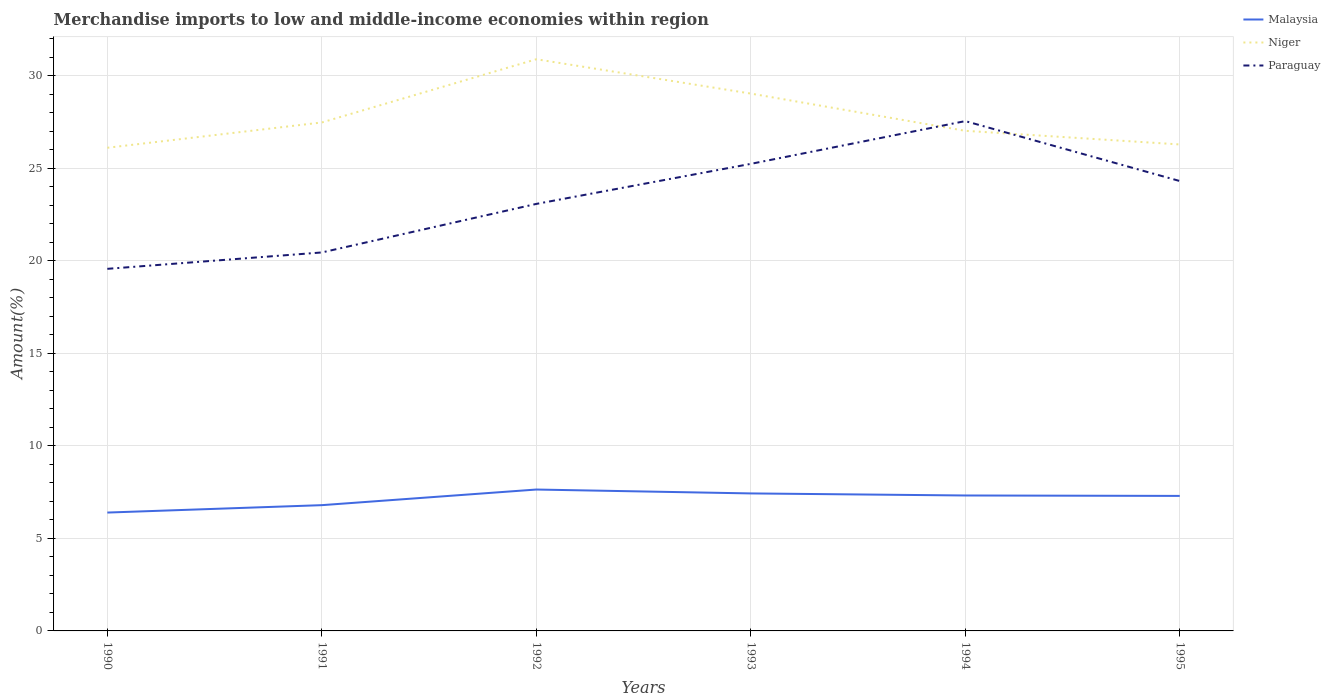Does the line corresponding to Paraguay intersect with the line corresponding to Malaysia?
Your answer should be very brief. No. Is the number of lines equal to the number of legend labels?
Your answer should be compact. Yes. Across all years, what is the maximum percentage of amount earned from merchandise imports in Malaysia?
Your answer should be very brief. 6.4. What is the total percentage of amount earned from merchandise imports in Malaysia in the graph?
Offer a terse response. -0.4. What is the difference between the highest and the second highest percentage of amount earned from merchandise imports in Malaysia?
Offer a very short reply. 1.24. What is the difference between the highest and the lowest percentage of amount earned from merchandise imports in Niger?
Provide a succinct answer. 2. Is the percentage of amount earned from merchandise imports in Niger strictly greater than the percentage of amount earned from merchandise imports in Paraguay over the years?
Offer a very short reply. No. How many lines are there?
Your response must be concise. 3. What is the difference between two consecutive major ticks on the Y-axis?
Make the answer very short. 5. Are the values on the major ticks of Y-axis written in scientific E-notation?
Provide a succinct answer. No. Does the graph contain grids?
Keep it short and to the point. Yes. How many legend labels are there?
Offer a terse response. 3. How are the legend labels stacked?
Make the answer very short. Vertical. What is the title of the graph?
Make the answer very short. Merchandise imports to low and middle-income economies within region. What is the label or title of the Y-axis?
Your answer should be compact. Amount(%). What is the Amount(%) of Malaysia in 1990?
Give a very brief answer. 6.4. What is the Amount(%) in Niger in 1990?
Provide a succinct answer. 26.11. What is the Amount(%) of Paraguay in 1990?
Give a very brief answer. 19.56. What is the Amount(%) in Malaysia in 1991?
Your answer should be very brief. 6.8. What is the Amount(%) of Niger in 1991?
Ensure brevity in your answer.  27.47. What is the Amount(%) of Paraguay in 1991?
Your response must be concise. 20.45. What is the Amount(%) in Malaysia in 1992?
Your answer should be compact. 7.64. What is the Amount(%) in Niger in 1992?
Your answer should be very brief. 30.89. What is the Amount(%) of Paraguay in 1992?
Make the answer very short. 23.07. What is the Amount(%) of Malaysia in 1993?
Make the answer very short. 7.43. What is the Amount(%) of Niger in 1993?
Offer a terse response. 29.03. What is the Amount(%) of Paraguay in 1993?
Provide a short and direct response. 25.24. What is the Amount(%) in Malaysia in 1994?
Your response must be concise. 7.32. What is the Amount(%) in Niger in 1994?
Offer a terse response. 27.02. What is the Amount(%) in Paraguay in 1994?
Your response must be concise. 27.55. What is the Amount(%) in Malaysia in 1995?
Your response must be concise. 7.3. What is the Amount(%) of Niger in 1995?
Offer a very short reply. 26.29. What is the Amount(%) in Paraguay in 1995?
Give a very brief answer. 24.31. Across all years, what is the maximum Amount(%) in Malaysia?
Your response must be concise. 7.64. Across all years, what is the maximum Amount(%) in Niger?
Provide a succinct answer. 30.89. Across all years, what is the maximum Amount(%) of Paraguay?
Make the answer very short. 27.55. Across all years, what is the minimum Amount(%) in Malaysia?
Make the answer very short. 6.4. Across all years, what is the minimum Amount(%) of Niger?
Offer a terse response. 26.11. Across all years, what is the minimum Amount(%) of Paraguay?
Your answer should be very brief. 19.56. What is the total Amount(%) in Malaysia in the graph?
Ensure brevity in your answer.  42.87. What is the total Amount(%) of Niger in the graph?
Provide a succinct answer. 166.81. What is the total Amount(%) of Paraguay in the graph?
Ensure brevity in your answer.  140.18. What is the difference between the Amount(%) in Malaysia in 1990 and that in 1991?
Your answer should be compact. -0.4. What is the difference between the Amount(%) in Niger in 1990 and that in 1991?
Provide a succinct answer. -1.37. What is the difference between the Amount(%) of Paraguay in 1990 and that in 1991?
Your answer should be compact. -0.89. What is the difference between the Amount(%) of Malaysia in 1990 and that in 1992?
Make the answer very short. -1.24. What is the difference between the Amount(%) in Niger in 1990 and that in 1992?
Offer a terse response. -4.78. What is the difference between the Amount(%) in Paraguay in 1990 and that in 1992?
Give a very brief answer. -3.51. What is the difference between the Amount(%) in Malaysia in 1990 and that in 1993?
Your response must be concise. -1.03. What is the difference between the Amount(%) of Niger in 1990 and that in 1993?
Offer a terse response. -2.93. What is the difference between the Amount(%) of Paraguay in 1990 and that in 1993?
Provide a short and direct response. -5.67. What is the difference between the Amount(%) in Malaysia in 1990 and that in 1994?
Provide a short and direct response. -0.92. What is the difference between the Amount(%) of Niger in 1990 and that in 1994?
Your response must be concise. -0.92. What is the difference between the Amount(%) of Paraguay in 1990 and that in 1994?
Your answer should be compact. -7.98. What is the difference between the Amount(%) in Malaysia in 1990 and that in 1995?
Ensure brevity in your answer.  -0.9. What is the difference between the Amount(%) in Niger in 1990 and that in 1995?
Ensure brevity in your answer.  -0.18. What is the difference between the Amount(%) in Paraguay in 1990 and that in 1995?
Provide a short and direct response. -4.74. What is the difference between the Amount(%) in Malaysia in 1991 and that in 1992?
Your answer should be very brief. -0.84. What is the difference between the Amount(%) of Niger in 1991 and that in 1992?
Offer a terse response. -3.42. What is the difference between the Amount(%) in Paraguay in 1991 and that in 1992?
Give a very brief answer. -2.62. What is the difference between the Amount(%) in Malaysia in 1991 and that in 1993?
Offer a very short reply. -0.63. What is the difference between the Amount(%) in Niger in 1991 and that in 1993?
Provide a succinct answer. -1.56. What is the difference between the Amount(%) in Paraguay in 1991 and that in 1993?
Give a very brief answer. -4.79. What is the difference between the Amount(%) of Malaysia in 1991 and that in 1994?
Your answer should be compact. -0.52. What is the difference between the Amount(%) in Niger in 1991 and that in 1994?
Give a very brief answer. 0.45. What is the difference between the Amount(%) of Paraguay in 1991 and that in 1994?
Your answer should be very brief. -7.1. What is the difference between the Amount(%) in Malaysia in 1991 and that in 1995?
Provide a succinct answer. -0.5. What is the difference between the Amount(%) in Niger in 1991 and that in 1995?
Make the answer very short. 1.19. What is the difference between the Amount(%) in Paraguay in 1991 and that in 1995?
Provide a succinct answer. -3.86. What is the difference between the Amount(%) of Malaysia in 1992 and that in 1993?
Provide a short and direct response. 0.21. What is the difference between the Amount(%) of Niger in 1992 and that in 1993?
Ensure brevity in your answer.  1.85. What is the difference between the Amount(%) in Paraguay in 1992 and that in 1993?
Your response must be concise. -2.16. What is the difference between the Amount(%) in Malaysia in 1992 and that in 1994?
Provide a short and direct response. 0.32. What is the difference between the Amount(%) of Niger in 1992 and that in 1994?
Your answer should be very brief. 3.87. What is the difference between the Amount(%) in Paraguay in 1992 and that in 1994?
Your response must be concise. -4.47. What is the difference between the Amount(%) in Malaysia in 1992 and that in 1995?
Make the answer very short. 0.34. What is the difference between the Amount(%) of Niger in 1992 and that in 1995?
Make the answer very short. 4.6. What is the difference between the Amount(%) of Paraguay in 1992 and that in 1995?
Provide a succinct answer. -1.24. What is the difference between the Amount(%) in Malaysia in 1993 and that in 1994?
Make the answer very short. 0.11. What is the difference between the Amount(%) in Niger in 1993 and that in 1994?
Your answer should be very brief. 2.01. What is the difference between the Amount(%) in Paraguay in 1993 and that in 1994?
Offer a terse response. -2.31. What is the difference between the Amount(%) of Malaysia in 1993 and that in 1995?
Provide a short and direct response. 0.13. What is the difference between the Amount(%) in Niger in 1993 and that in 1995?
Your response must be concise. 2.75. What is the difference between the Amount(%) in Paraguay in 1993 and that in 1995?
Ensure brevity in your answer.  0.93. What is the difference between the Amount(%) of Malaysia in 1994 and that in 1995?
Offer a very short reply. 0.02. What is the difference between the Amount(%) in Niger in 1994 and that in 1995?
Your response must be concise. 0.74. What is the difference between the Amount(%) of Paraguay in 1994 and that in 1995?
Ensure brevity in your answer.  3.24. What is the difference between the Amount(%) in Malaysia in 1990 and the Amount(%) in Niger in 1991?
Your answer should be very brief. -21.08. What is the difference between the Amount(%) of Malaysia in 1990 and the Amount(%) of Paraguay in 1991?
Provide a succinct answer. -14.05. What is the difference between the Amount(%) of Niger in 1990 and the Amount(%) of Paraguay in 1991?
Provide a short and direct response. 5.66. What is the difference between the Amount(%) in Malaysia in 1990 and the Amount(%) in Niger in 1992?
Provide a succinct answer. -24.49. What is the difference between the Amount(%) in Malaysia in 1990 and the Amount(%) in Paraguay in 1992?
Your answer should be very brief. -16.68. What is the difference between the Amount(%) in Niger in 1990 and the Amount(%) in Paraguay in 1992?
Give a very brief answer. 3.03. What is the difference between the Amount(%) of Malaysia in 1990 and the Amount(%) of Niger in 1993?
Give a very brief answer. -22.64. What is the difference between the Amount(%) of Malaysia in 1990 and the Amount(%) of Paraguay in 1993?
Keep it short and to the point. -18.84. What is the difference between the Amount(%) of Niger in 1990 and the Amount(%) of Paraguay in 1993?
Offer a terse response. 0.87. What is the difference between the Amount(%) in Malaysia in 1990 and the Amount(%) in Niger in 1994?
Give a very brief answer. -20.63. What is the difference between the Amount(%) of Malaysia in 1990 and the Amount(%) of Paraguay in 1994?
Provide a succinct answer. -21.15. What is the difference between the Amount(%) in Niger in 1990 and the Amount(%) in Paraguay in 1994?
Ensure brevity in your answer.  -1.44. What is the difference between the Amount(%) of Malaysia in 1990 and the Amount(%) of Niger in 1995?
Offer a very short reply. -19.89. What is the difference between the Amount(%) of Malaysia in 1990 and the Amount(%) of Paraguay in 1995?
Provide a succinct answer. -17.91. What is the difference between the Amount(%) in Niger in 1990 and the Amount(%) in Paraguay in 1995?
Your response must be concise. 1.8. What is the difference between the Amount(%) of Malaysia in 1991 and the Amount(%) of Niger in 1992?
Provide a succinct answer. -24.09. What is the difference between the Amount(%) in Malaysia in 1991 and the Amount(%) in Paraguay in 1992?
Ensure brevity in your answer.  -16.28. What is the difference between the Amount(%) in Niger in 1991 and the Amount(%) in Paraguay in 1992?
Keep it short and to the point. 4.4. What is the difference between the Amount(%) of Malaysia in 1991 and the Amount(%) of Niger in 1993?
Your answer should be compact. -22.24. What is the difference between the Amount(%) in Malaysia in 1991 and the Amount(%) in Paraguay in 1993?
Provide a succinct answer. -18.44. What is the difference between the Amount(%) in Niger in 1991 and the Amount(%) in Paraguay in 1993?
Offer a very short reply. 2.24. What is the difference between the Amount(%) of Malaysia in 1991 and the Amount(%) of Niger in 1994?
Give a very brief answer. -20.23. What is the difference between the Amount(%) in Malaysia in 1991 and the Amount(%) in Paraguay in 1994?
Give a very brief answer. -20.75. What is the difference between the Amount(%) in Niger in 1991 and the Amount(%) in Paraguay in 1994?
Ensure brevity in your answer.  -0.07. What is the difference between the Amount(%) in Malaysia in 1991 and the Amount(%) in Niger in 1995?
Provide a short and direct response. -19.49. What is the difference between the Amount(%) of Malaysia in 1991 and the Amount(%) of Paraguay in 1995?
Provide a succinct answer. -17.51. What is the difference between the Amount(%) of Niger in 1991 and the Amount(%) of Paraguay in 1995?
Give a very brief answer. 3.16. What is the difference between the Amount(%) of Malaysia in 1992 and the Amount(%) of Niger in 1993?
Your answer should be very brief. -21.39. What is the difference between the Amount(%) in Malaysia in 1992 and the Amount(%) in Paraguay in 1993?
Offer a terse response. -17.6. What is the difference between the Amount(%) in Niger in 1992 and the Amount(%) in Paraguay in 1993?
Your response must be concise. 5.65. What is the difference between the Amount(%) in Malaysia in 1992 and the Amount(%) in Niger in 1994?
Your response must be concise. -19.38. What is the difference between the Amount(%) in Malaysia in 1992 and the Amount(%) in Paraguay in 1994?
Offer a very short reply. -19.91. What is the difference between the Amount(%) in Niger in 1992 and the Amount(%) in Paraguay in 1994?
Offer a terse response. 3.34. What is the difference between the Amount(%) in Malaysia in 1992 and the Amount(%) in Niger in 1995?
Your answer should be compact. -18.65. What is the difference between the Amount(%) in Malaysia in 1992 and the Amount(%) in Paraguay in 1995?
Your answer should be very brief. -16.67. What is the difference between the Amount(%) in Niger in 1992 and the Amount(%) in Paraguay in 1995?
Offer a very short reply. 6.58. What is the difference between the Amount(%) of Malaysia in 1993 and the Amount(%) of Niger in 1994?
Your answer should be very brief. -19.59. What is the difference between the Amount(%) of Malaysia in 1993 and the Amount(%) of Paraguay in 1994?
Offer a very short reply. -20.12. What is the difference between the Amount(%) of Niger in 1993 and the Amount(%) of Paraguay in 1994?
Give a very brief answer. 1.49. What is the difference between the Amount(%) in Malaysia in 1993 and the Amount(%) in Niger in 1995?
Provide a short and direct response. -18.86. What is the difference between the Amount(%) in Malaysia in 1993 and the Amount(%) in Paraguay in 1995?
Your answer should be compact. -16.88. What is the difference between the Amount(%) of Niger in 1993 and the Amount(%) of Paraguay in 1995?
Your answer should be very brief. 4.73. What is the difference between the Amount(%) in Malaysia in 1994 and the Amount(%) in Niger in 1995?
Give a very brief answer. -18.97. What is the difference between the Amount(%) of Malaysia in 1994 and the Amount(%) of Paraguay in 1995?
Make the answer very short. -16.99. What is the difference between the Amount(%) in Niger in 1994 and the Amount(%) in Paraguay in 1995?
Ensure brevity in your answer.  2.71. What is the average Amount(%) of Malaysia per year?
Your answer should be very brief. 7.15. What is the average Amount(%) in Niger per year?
Offer a terse response. 27.8. What is the average Amount(%) of Paraguay per year?
Ensure brevity in your answer.  23.36. In the year 1990, what is the difference between the Amount(%) of Malaysia and Amount(%) of Niger?
Your answer should be compact. -19.71. In the year 1990, what is the difference between the Amount(%) of Malaysia and Amount(%) of Paraguay?
Give a very brief answer. -13.17. In the year 1990, what is the difference between the Amount(%) of Niger and Amount(%) of Paraguay?
Give a very brief answer. 6.54. In the year 1991, what is the difference between the Amount(%) in Malaysia and Amount(%) in Niger?
Your answer should be compact. -20.68. In the year 1991, what is the difference between the Amount(%) in Malaysia and Amount(%) in Paraguay?
Your answer should be very brief. -13.65. In the year 1991, what is the difference between the Amount(%) in Niger and Amount(%) in Paraguay?
Provide a succinct answer. 7.02. In the year 1992, what is the difference between the Amount(%) of Malaysia and Amount(%) of Niger?
Your answer should be very brief. -23.25. In the year 1992, what is the difference between the Amount(%) of Malaysia and Amount(%) of Paraguay?
Provide a short and direct response. -15.43. In the year 1992, what is the difference between the Amount(%) in Niger and Amount(%) in Paraguay?
Your response must be concise. 7.82. In the year 1993, what is the difference between the Amount(%) of Malaysia and Amount(%) of Niger?
Ensure brevity in your answer.  -21.6. In the year 1993, what is the difference between the Amount(%) in Malaysia and Amount(%) in Paraguay?
Keep it short and to the point. -17.81. In the year 1993, what is the difference between the Amount(%) of Niger and Amount(%) of Paraguay?
Your answer should be very brief. 3.8. In the year 1994, what is the difference between the Amount(%) of Malaysia and Amount(%) of Niger?
Give a very brief answer. -19.7. In the year 1994, what is the difference between the Amount(%) in Malaysia and Amount(%) in Paraguay?
Ensure brevity in your answer.  -20.23. In the year 1994, what is the difference between the Amount(%) of Niger and Amount(%) of Paraguay?
Provide a short and direct response. -0.52. In the year 1995, what is the difference between the Amount(%) of Malaysia and Amount(%) of Niger?
Your answer should be compact. -18.99. In the year 1995, what is the difference between the Amount(%) of Malaysia and Amount(%) of Paraguay?
Keep it short and to the point. -17.01. In the year 1995, what is the difference between the Amount(%) of Niger and Amount(%) of Paraguay?
Make the answer very short. 1.98. What is the ratio of the Amount(%) in Malaysia in 1990 to that in 1991?
Ensure brevity in your answer.  0.94. What is the ratio of the Amount(%) in Niger in 1990 to that in 1991?
Make the answer very short. 0.95. What is the ratio of the Amount(%) in Paraguay in 1990 to that in 1991?
Your answer should be compact. 0.96. What is the ratio of the Amount(%) in Malaysia in 1990 to that in 1992?
Provide a succinct answer. 0.84. What is the ratio of the Amount(%) of Niger in 1990 to that in 1992?
Offer a very short reply. 0.85. What is the ratio of the Amount(%) of Paraguay in 1990 to that in 1992?
Your answer should be compact. 0.85. What is the ratio of the Amount(%) of Malaysia in 1990 to that in 1993?
Your answer should be compact. 0.86. What is the ratio of the Amount(%) of Niger in 1990 to that in 1993?
Provide a short and direct response. 0.9. What is the ratio of the Amount(%) of Paraguay in 1990 to that in 1993?
Keep it short and to the point. 0.78. What is the ratio of the Amount(%) of Malaysia in 1990 to that in 1994?
Provide a short and direct response. 0.87. What is the ratio of the Amount(%) of Niger in 1990 to that in 1994?
Keep it short and to the point. 0.97. What is the ratio of the Amount(%) of Paraguay in 1990 to that in 1994?
Your answer should be compact. 0.71. What is the ratio of the Amount(%) in Malaysia in 1990 to that in 1995?
Make the answer very short. 0.88. What is the ratio of the Amount(%) in Paraguay in 1990 to that in 1995?
Offer a very short reply. 0.8. What is the ratio of the Amount(%) in Malaysia in 1991 to that in 1992?
Keep it short and to the point. 0.89. What is the ratio of the Amount(%) in Niger in 1991 to that in 1992?
Make the answer very short. 0.89. What is the ratio of the Amount(%) of Paraguay in 1991 to that in 1992?
Your answer should be compact. 0.89. What is the ratio of the Amount(%) in Malaysia in 1991 to that in 1993?
Provide a succinct answer. 0.91. What is the ratio of the Amount(%) of Niger in 1991 to that in 1993?
Provide a short and direct response. 0.95. What is the ratio of the Amount(%) in Paraguay in 1991 to that in 1993?
Your answer should be very brief. 0.81. What is the ratio of the Amount(%) in Malaysia in 1991 to that in 1994?
Provide a succinct answer. 0.93. What is the ratio of the Amount(%) in Niger in 1991 to that in 1994?
Keep it short and to the point. 1.02. What is the ratio of the Amount(%) in Paraguay in 1991 to that in 1994?
Offer a terse response. 0.74. What is the ratio of the Amount(%) of Malaysia in 1991 to that in 1995?
Your answer should be very brief. 0.93. What is the ratio of the Amount(%) of Niger in 1991 to that in 1995?
Ensure brevity in your answer.  1.05. What is the ratio of the Amount(%) of Paraguay in 1991 to that in 1995?
Offer a very short reply. 0.84. What is the ratio of the Amount(%) of Malaysia in 1992 to that in 1993?
Offer a very short reply. 1.03. What is the ratio of the Amount(%) of Niger in 1992 to that in 1993?
Offer a very short reply. 1.06. What is the ratio of the Amount(%) of Paraguay in 1992 to that in 1993?
Ensure brevity in your answer.  0.91. What is the ratio of the Amount(%) of Malaysia in 1992 to that in 1994?
Offer a terse response. 1.04. What is the ratio of the Amount(%) of Niger in 1992 to that in 1994?
Offer a very short reply. 1.14. What is the ratio of the Amount(%) of Paraguay in 1992 to that in 1994?
Make the answer very short. 0.84. What is the ratio of the Amount(%) in Malaysia in 1992 to that in 1995?
Your answer should be very brief. 1.05. What is the ratio of the Amount(%) in Niger in 1992 to that in 1995?
Provide a succinct answer. 1.18. What is the ratio of the Amount(%) of Paraguay in 1992 to that in 1995?
Offer a terse response. 0.95. What is the ratio of the Amount(%) in Malaysia in 1993 to that in 1994?
Your answer should be very brief. 1.02. What is the ratio of the Amount(%) in Niger in 1993 to that in 1994?
Your response must be concise. 1.07. What is the ratio of the Amount(%) of Paraguay in 1993 to that in 1994?
Give a very brief answer. 0.92. What is the ratio of the Amount(%) of Malaysia in 1993 to that in 1995?
Ensure brevity in your answer.  1.02. What is the ratio of the Amount(%) of Niger in 1993 to that in 1995?
Your response must be concise. 1.1. What is the ratio of the Amount(%) of Paraguay in 1993 to that in 1995?
Offer a very short reply. 1.04. What is the ratio of the Amount(%) of Malaysia in 1994 to that in 1995?
Keep it short and to the point. 1. What is the ratio of the Amount(%) in Niger in 1994 to that in 1995?
Make the answer very short. 1.03. What is the ratio of the Amount(%) in Paraguay in 1994 to that in 1995?
Provide a succinct answer. 1.13. What is the difference between the highest and the second highest Amount(%) in Malaysia?
Offer a very short reply. 0.21. What is the difference between the highest and the second highest Amount(%) of Niger?
Provide a succinct answer. 1.85. What is the difference between the highest and the second highest Amount(%) in Paraguay?
Make the answer very short. 2.31. What is the difference between the highest and the lowest Amount(%) in Malaysia?
Offer a very short reply. 1.24. What is the difference between the highest and the lowest Amount(%) of Niger?
Give a very brief answer. 4.78. What is the difference between the highest and the lowest Amount(%) of Paraguay?
Provide a succinct answer. 7.98. 